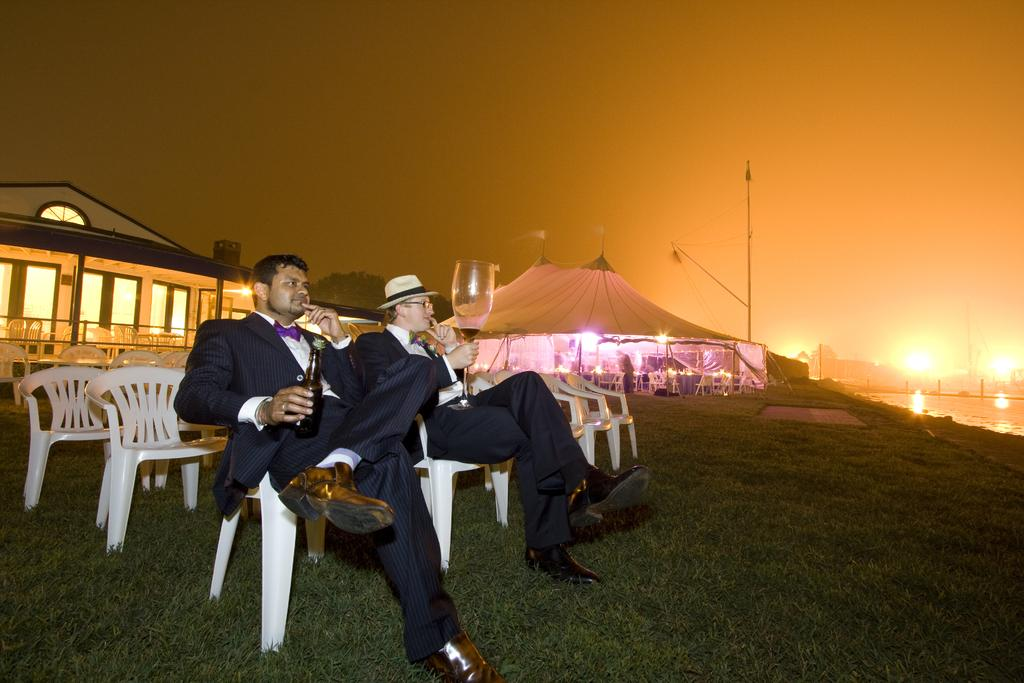How many people are sitting in the image? There are two people sitting on chairs in the image. What are the people holding in their hands? The people are holding objects in the image. Can you describe the additional furniture in the image? There are additional chairs in the image. What type of lighting is present in the image? There are lights in the image. What are the tall, vertical structures in the image? There are poles in the image. What type of natural environment is visible in the image? There is grass and water visible in the image. What type of shelter is present in the image? There is a tent in the image. What type of building is present in the image? There is a house in the image. What type of bead is used to decorate the chairs in the image? There is no mention of beads being used to decorate the chairs in the image. What type of seat is present on the poles in the image? There are no seats present on the poles in the image. 